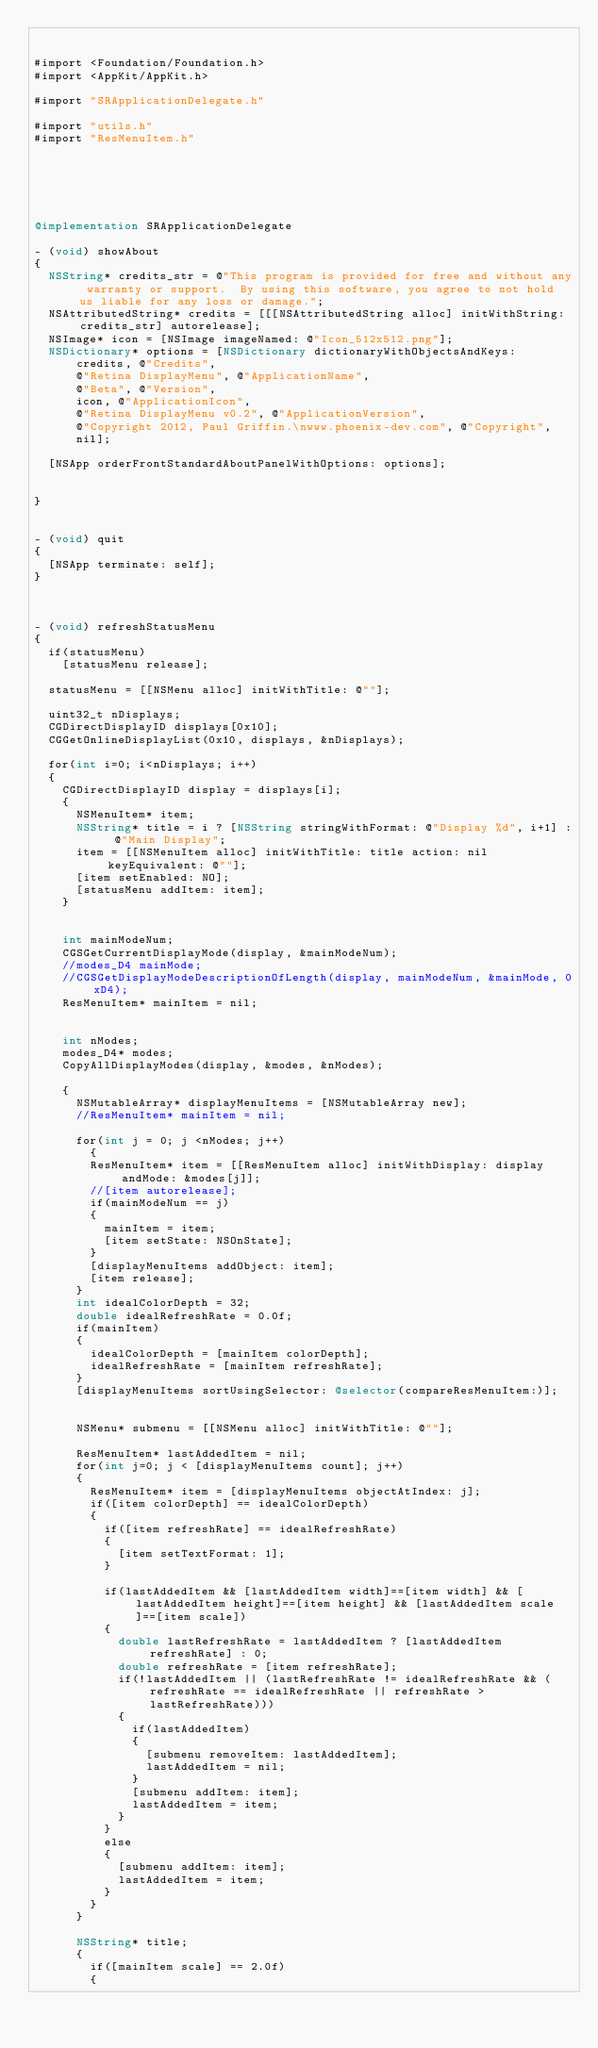Convert code to text. <code><loc_0><loc_0><loc_500><loc_500><_ObjectiveC_>

#import <Foundation/Foundation.h>
#import <AppKit/AppKit.h>

#import "SRApplicationDelegate.h"

#import "utils.h"
#import "ResMenuItem.h"






@implementation SRApplicationDelegate

- (void) showAbout
{
	NSString* credits_str = @"This program is provided for free and without any warranty or support.  By using this software, you agree to not hold us liable for any loss or damage.";
	NSAttributedString* credits = [[[NSAttributedString alloc] initWithString: credits_str] autorelease];
	NSImage* icon = [NSImage imageNamed: @"Icon_512x512.png"];
	NSDictionary* options = [NSDictionary dictionaryWithObjectsAndKeys:
			credits, @"Credits",
			@"Retina DisplayMenu", @"ApplicationName",
			@"Beta", @"Version",
			icon, @"ApplicationIcon",
			@"Retina DisplayMenu v0.2", @"ApplicationVersion",
			@"Copyright 2012, Paul Griffin.\nwww.phoenix-dev.com", @"Copyright",
			nil];
	
	[NSApp orderFrontStandardAboutPanelWithOptions: options];
				
	
}


- (void) quit
{
	[NSApp terminate: self];
}



- (void) refreshStatusMenu
{
	if(statusMenu)
		[statusMenu release];
	
	statusMenu = [[NSMenu alloc] initWithTitle: @""];
	
	uint32_t nDisplays;
	CGDirectDisplayID displays[0x10];
	CGGetOnlineDisplayList(0x10, displays, &nDisplays);
	
	for(int i=0; i<nDisplays; i++)
	{
		CGDirectDisplayID display = displays[i];
		{
			NSMenuItem* item;
			NSString* title = i ? [NSString stringWithFormat: @"Display %d", i+1] : @"Main Display";
			item = [[NSMenuItem alloc] initWithTitle: title action: nil keyEquivalent: @""];
			[item setEnabled: NO];
			[statusMenu addItem: item];
		}
		
		
		int mainModeNum;
		CGSGetCurrentDisplayMode(display, &mainModeNum);
		//modes_D4 mainMode;
		//CGSGetDisplayModeDescriptionOfLength(display, mainModeNum, &mainMode, 0xD4);
		ResMenuItem* mainItem = nil;
		
		
		int nModes;
		modes_D4* modes;
		CopyAllDisplayModes(display, &modes, &nModes);
		
		{
			NSMutableArray* displayMenuItems = [NSMutableArray new];
			//ResMenuItem* mainItem = nil;
			
			for(int j = 0; j <nModes; j++)
		    {
				ResMenuItem* item = [[ResMenuItem alloc] initWithDisplay: display andMode: &modes[j]];
				//[item autorelease];
				if(mainModeNum == j)
				{
					mainItem = item;
					[item setState: NSOnState];	
				}
				[displayMenuItems addObject: item];
				[item release];
			}
			int idealColorDepth = 32;
			double idealRefreshRate = 0.0f;
			if(mainItem)
			{
				idealColorDepth = [mainItem colorDepth];
				idealRefreshRate = [mainItem refreshRate];
			}
			[displayMenuItems sortUsingSelector: @selector(compareResMenuItem:)];
		
		
			NSMenu* submenu = [[NSMenu alloc] initWithTitle: @""];
			
			ResMenuItem* lastAddedItem = nil;
			for(int j=0; j < [displayMenuItems count]; j++)
			{
				ResMenuItem* item = [displayMenuItems objectAtIndex: j];
				if([item colorDepth] == idealColorDepth)
				{
					if([item refreshRate] == idealRefreshRate)
					{
						[item setTextFormat: 1];
					}
					
					if(lastAddedItem && [lastAddedItem width]==[item width] && [lastAddedItem height]==[item height] && [lastAddedItem scale]==[item scale])
					{
						double lastRefreshRate = lastAddedItem ? [lastAddedItem refreshRate] : 0;
						double refreshRate = [item refreshRate];
						if(!lastAddedItem || (lastRefreshRate != idealRefreshRate && (refreshRate == idealRefreshRate || refreshRate > lastRefreshRate)))
						{
							if(lastAddedItem)
							{
								[submenu removeItem: lastAddedItem];
								lastAddedItem = nil;
							}
							[submenu addItem: item];
							lastAddedItem = item;
						}
					}
					else
					{	
						[submenu addItem: item];
						lastAddedItem = item;
					}
				}
			}
			
			NSString* title;
			{
				if([mainItem scale] == 2.0f)
				{</code> 